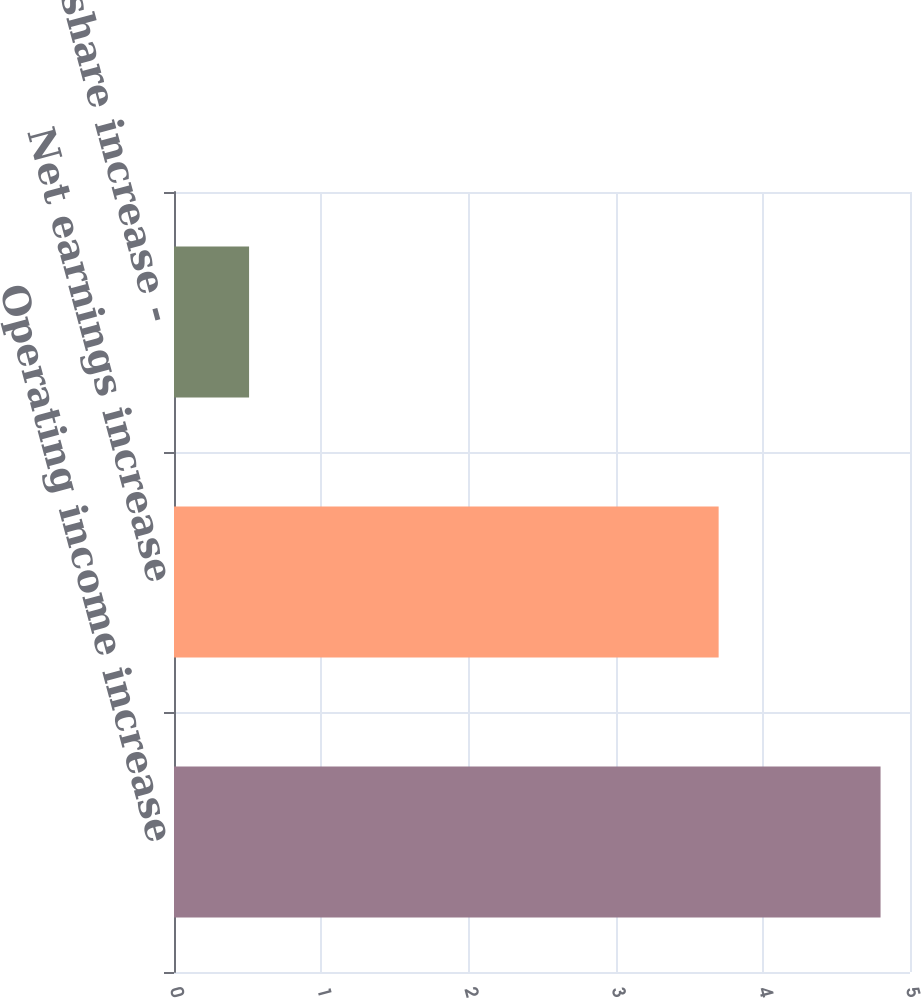Convert chart. <chart><loc_0><loc_0><loc_500><loc_500><bar_chart><fcel>Operating income increase<fcel>Net earnings increase<fcel>Earnings per share increase -<nl><fcel>4.8<fcel>3.7<fcel>0.51<nl></chart> 